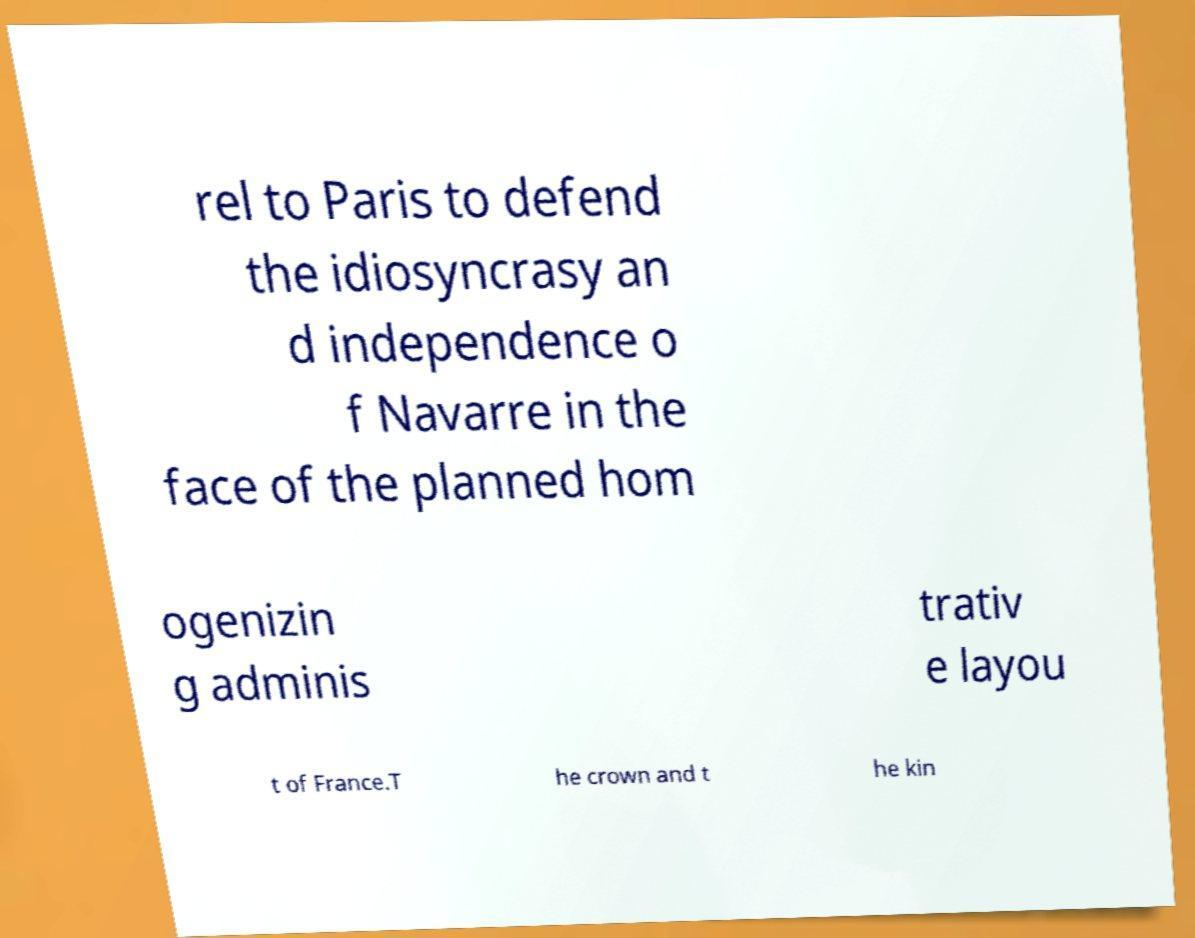Could you assist in decoding the text presented in this image and type it out clearly? rel to Paris to defend the idiosyncrasy an d independence o f Navarre in the face of the planned hom ogenizin g adminis trativ e layou t of France.T he crown and t he kin 